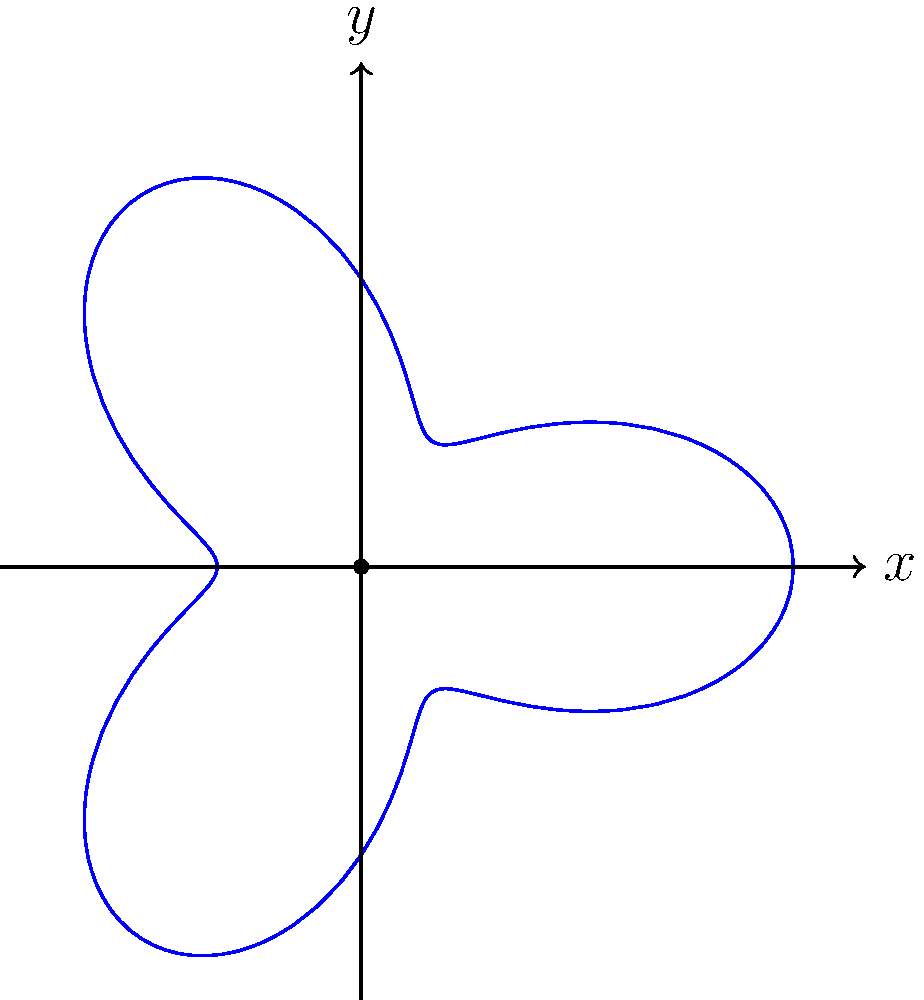In a circular courtroom, evidence is distributed according to the polar equation $r = 2 + \cos(3\theta)$. What is the maximum distance from the center of the courtroom at which evidence can be found? To find the maximum distance from the center, we need to follow these steps:

1) The given polar equation is $r = 2 + \cos(3\theta)$.

2) The maximum value of $r$ will occur when $\cos(3\theta)$ is at its maximum.

3) We know that the maximum value of cosine is 1.

4) Therefore, the maximum value of $r$ will be:

   $r_{max} = 2 + 1 = 3$

5) This means that the evidence can be found at a maximum distance of 3 units from the center of the courtroom.

This problem demonstrates how polar coordinates can be used to model complex distributions in a circular space, which could be relevant in analyzing evidence placement in a courtroom setting.
Answer: 3 units 